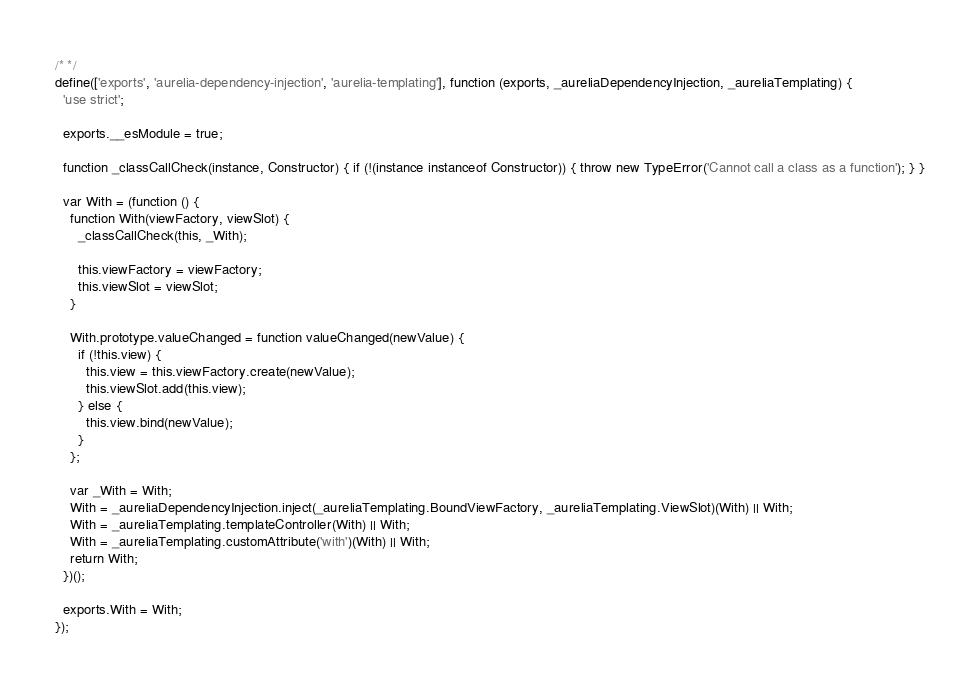<code> <loc_0><loc_0><loc_500><loc_500><_JavaScript_>/* */ 
define(['exports', 'aurelia-dependency-injection', 'aurelia-templating'], function (exports, _aureliaDependencyInjection, _aureliaTemplating) {
  'use strict';

  exports.__esModule = true;

  function _classCallCheck(instance, Constructor) { if (!(instance instanceof Constructor)) { throw new TypeError('Cannot call a class as a function'); } }

  var With = (function () {
    function With(viewFactory, viewSlot) {
      _classCallCheck(this, _With);

      this.viewFactory = viewFactory;
      this.viewSlot = viewSlot;
    }

    With.prototype.valueChanged = function valueChanged(newValue) {
      if (!this.view) {
        this.view = this.viewFactory.create(newValue);
        this.viewSlot.add(this.view);
      } else {
        this.view.bind(newValue);
      }
    };

    var _With = With;
    With = _aureliaDependencyInjection.inject(_aureliaTemplating.BoundViewFactory, _aureliaTemplating.ViewSlot)(With) || With;
    With = _aureliaTemplating.templateController(With) || With;
    With = _aureliaTemplating.customAttribute('with')(With) || With;
    return With;
  })();

  exports.With = With;
});</code> 